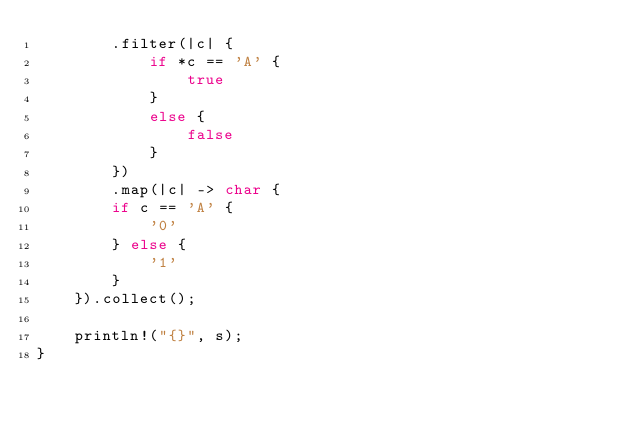<code> <loc_0><loc_0><loc_500><loc_500><_Rust_>        .filter(|c| {
            if *c == 'A' {
                true
            }
            else {
                false
            }
        })
        .map(|c| -> char {
        if c == 'A' {
            '0'
        } else {
            '1'
        }
    }).collect();
    
    println!("{}", s);
}
</code> 